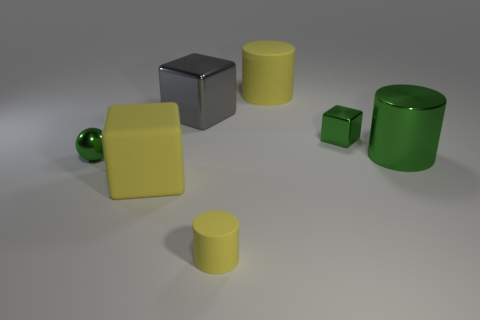Subtract all gray balls. How many yellow cylinders are left? 2 Subtract all metallic cubes. How many cubes are left? 1 Add 1 green blocks. How many objects exist? 8 Subtract all blocks. How many objects are left? 4 Subtract all small metallic spheres. Subtract all shiny cylinders. How many objects are left? 5 Add 6 small green metal spheres. How many small green metal spheres are left? 7 Add 3 yellow things. How many yellow things exist? 6 Subtract 0 blue spheres. How many objects are left? 7 